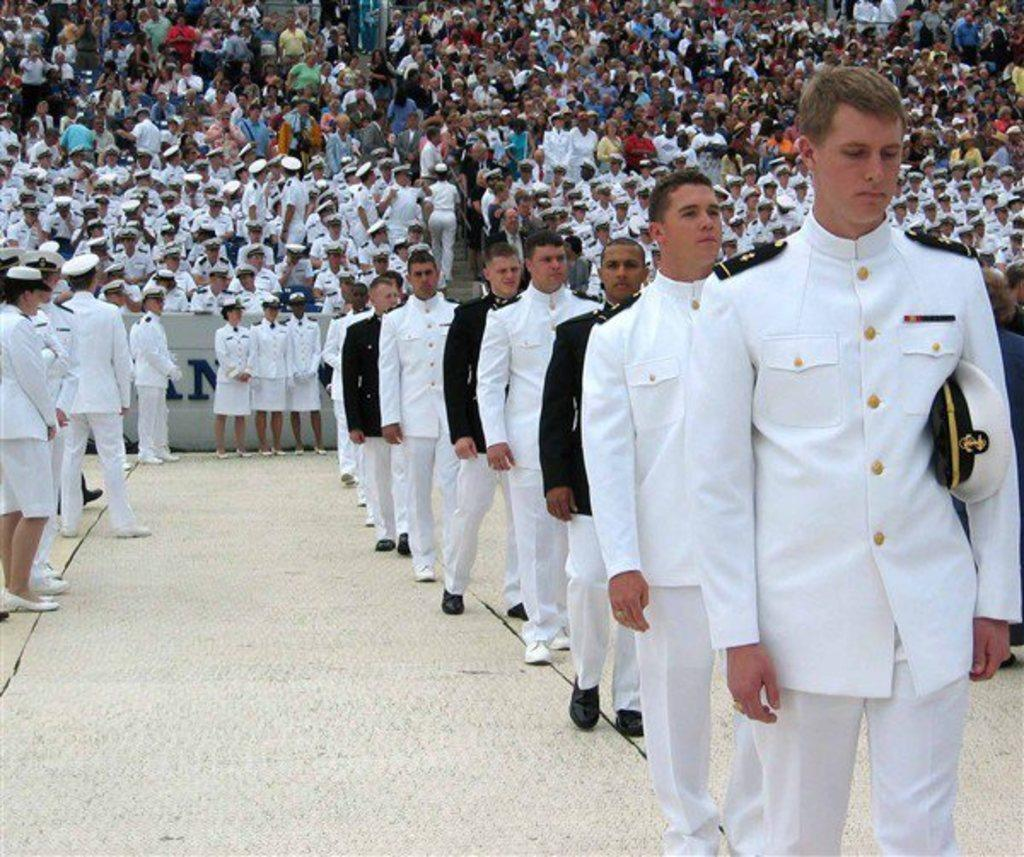What are the people in the image doing? There are people standing on the ground and sitting on chairs in the image. What is the position of the people sitting on chairs? The people sitting on chairs are in a seated position. What are the people on the chairs focused on? The people on the chairs are watching something. What type of operation is being performed on the hill in the image? There is no hill or operation present in the image; it features people standing and sitting. Can you see any needles in the image? There are no needles visible in the image. 